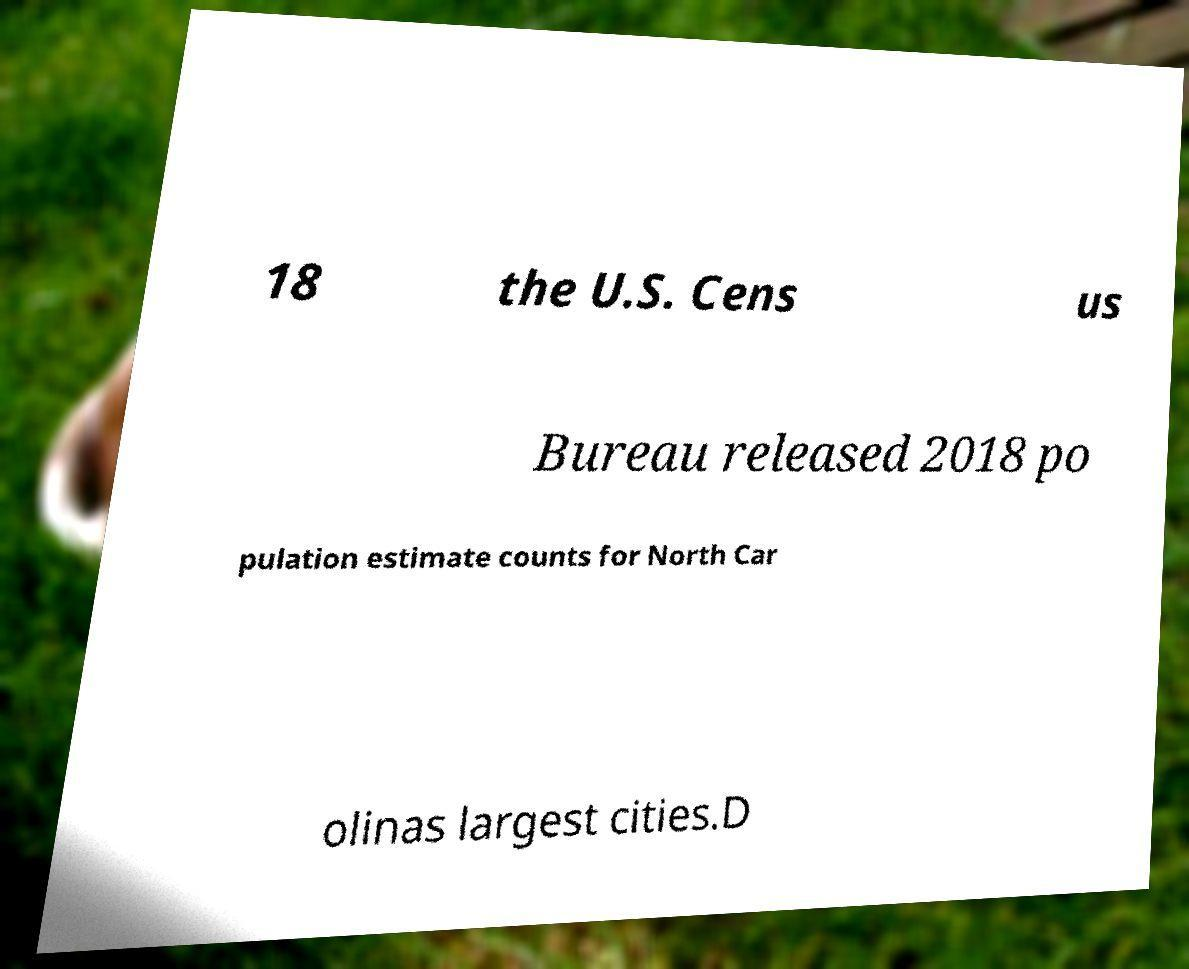Can you accurately transcribe the text from the provided image for me? 18 the U.S. Cens us Bureau released 2018 po pulation estimate counts for North Car olinas largest cities.D 